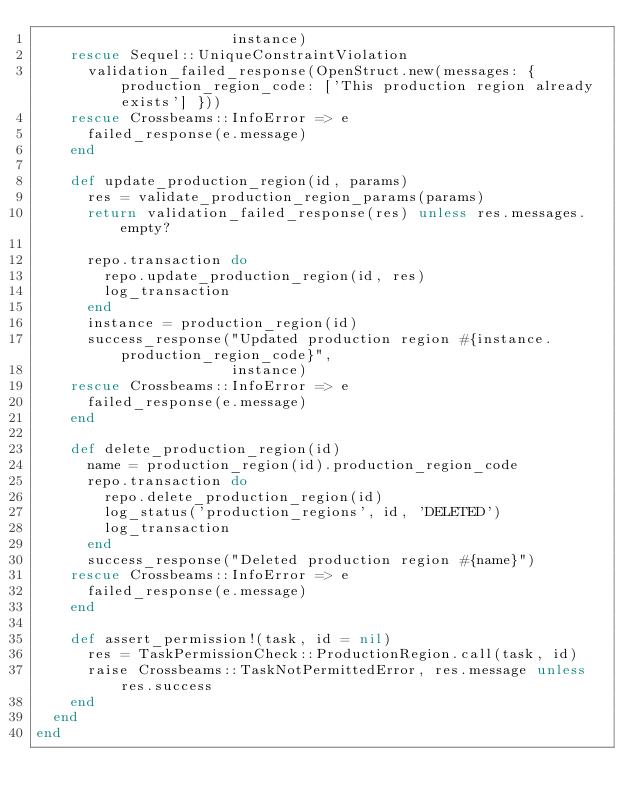Convert code to text. <code><loc_0><loc_0><loc_500><loc_500><_Ruby_>                       instance)
    rescue Sequel::UniqueConstraintViolation
      validation_failed_response(OpenStruct.new(messages: { production_region_code: ['This production region already exists'] }))
    rescue Crossbeams::InfoError => e
      failed_response(e.message)
    end

    def update_production_region(id, params)
      res = validate_production_region_params(params)
      return validation_failed_response(res) unless res.messages.empty?

      repo.transaction do
        repo.update_production_region(id, res)
        log_transaction
      end
      instance = production_region(id)
      success_response("Updated production region #{instance.production_region_code}",
                       instance)
    rescue Crossbeams::InfoError => e
      failed_response(e.message)
    end

    def delete_production_region(id)
      name = production_region(id).production_region_code
      repo.transaction do
        repo.delete_production_region(id)
        log_status('production_regions', id, 'DELETED')
        log_transaction
      end
      success_response("Deleted production region #{name}")
    rescue Crossbeams::InfoError => e
      failed_response(e.message)
    end

    def assert_permission!(task, id = nil)
      res = TaskPermissionCheck::ProductionRegion.call(task, id)
      raise Crossbeams::TaskNotPermittedError, res.message unless res.success
    end
  end
end
</code> 